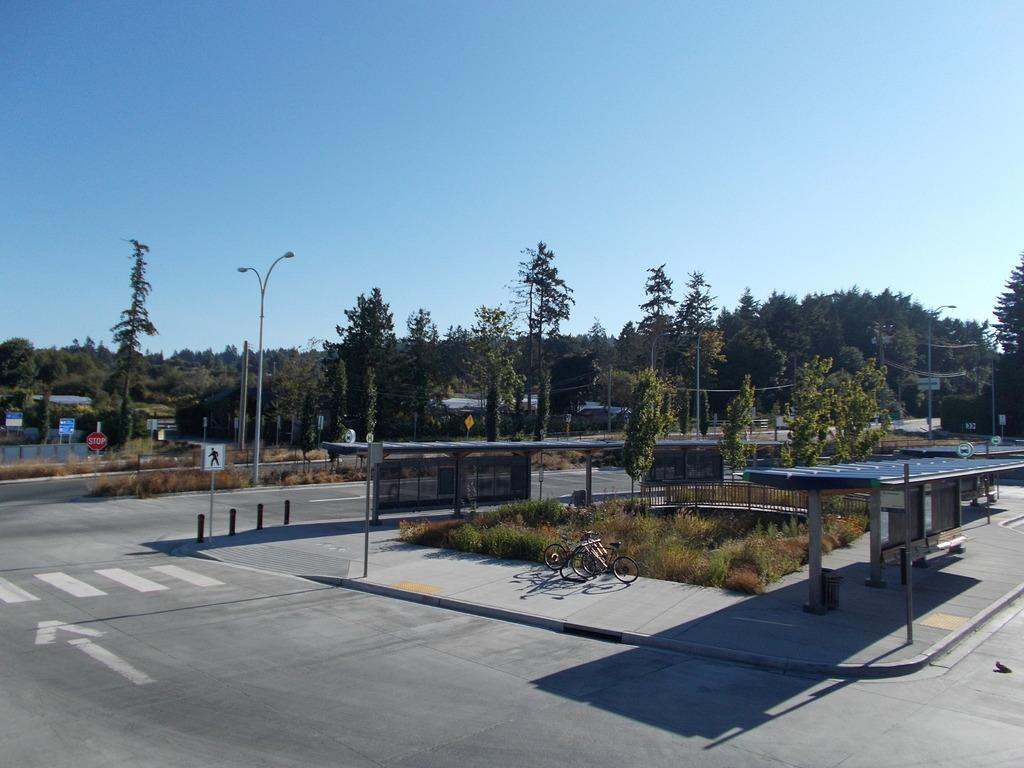What type of pathway is visible in the image? There is a road in the image. What type of structure can be seen near the road? There is a shed in the image. What type of lighting is present along the road? There are street lights in the image. What type of transportation can be seen on the pavement? There are bicycles on the pavement in the image. What type of barrier is present along the road? There is an iron fence in the image. What type of information is displayed in the image? There are sign boards in the image. What type of natural elements can be seen in the background of the image? There are trees in the background of the image. What type of sky is visible in the background of the image? There is sky visible in the background of the image. What type of pot is visible on the wrist of the person in the image? There is no person or pot visible in the image. What type of lock is present on the shed in the image? The image does not show a lock on the shed, only the shed itself. 